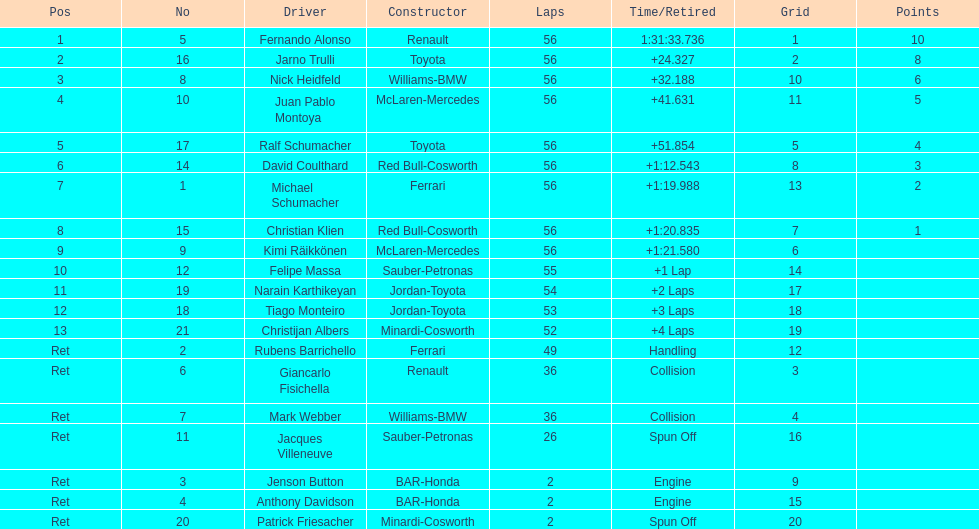For the competitor who secured the 1st position, what was their completed lap count? 56. 